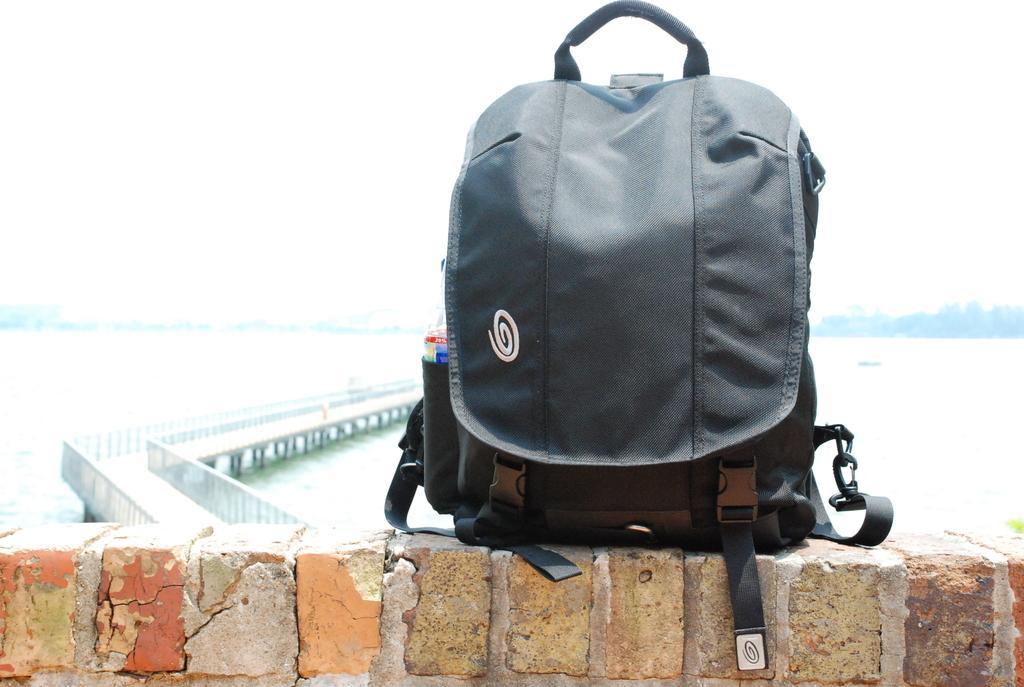In one or two sentences, can you explain what this image depicts? In this picture there is a black color bag. The bag is on a wall. Background of the wall is a bridge, water and sky. 